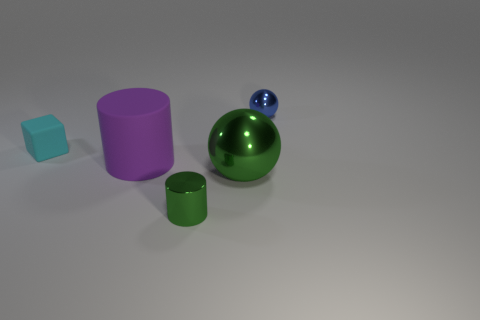Add 2 small cyan objects. How many objects exist? 7 Subtract all balls. How many objects are left? 3 Add 3 tiny rubber cubes. How many tiny rubber cubes are left? 4 Add 5 small cyan rubber objects. How many small cyan rubber objects exist? 6 Subtract 0 purple balls. How many objects are left? 5 Subtract all purple rubber things. Subtract all tiny green objects. How many objects are left? 3 